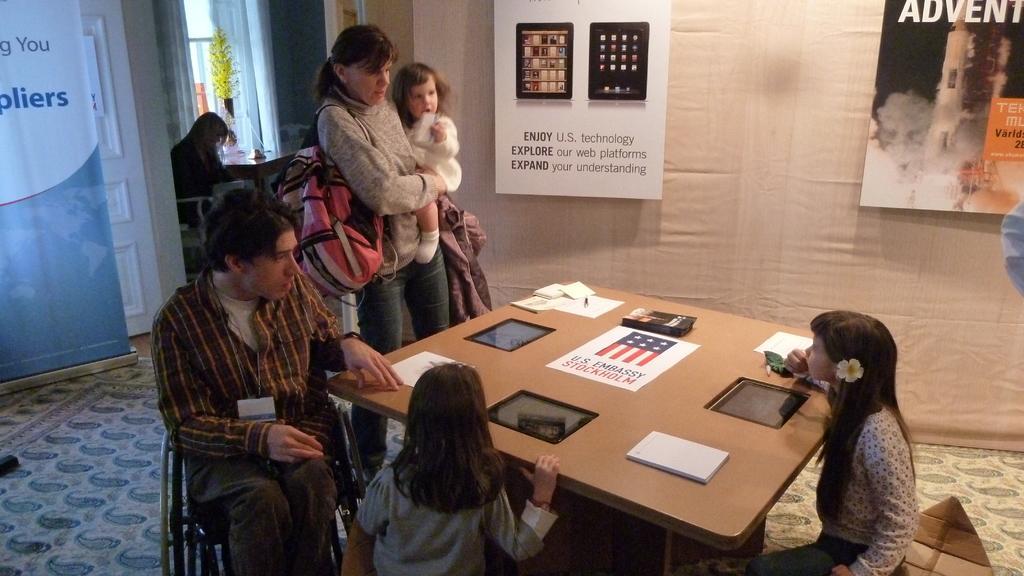In one or two sentences, can you explain what this image depicts? In this image I can see few people are in front of the table and one person is wearing the bag. On the table there are papers. In the back ground a person sitting on the chair and the boards to the wall. 